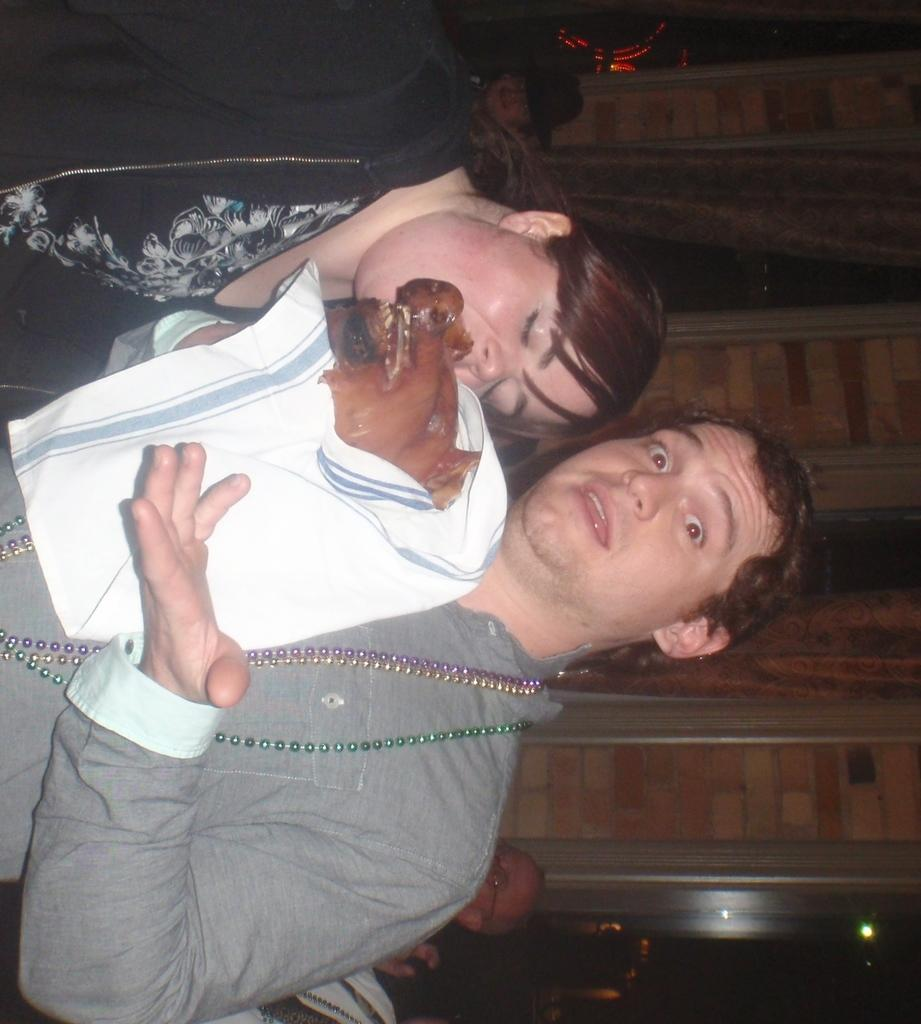How many people are present in the image? There are two people, a man and a woman, present in the image. What is the man wearing in the image? The man is wearing chains in the image. What is the man holding in the image? The man is holding something in a white cloth in the image. What can be seen in the background of the image? There are people and a brick wall in the background of the image. What type of apple is the man shaking from the tree in the image? There is no apple or tree present in the image. 